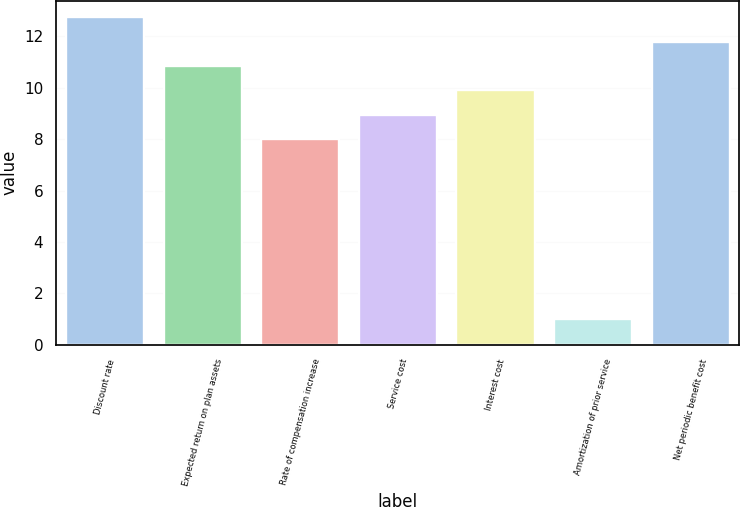Convert chart. <chart><loc_0><loc_0><loc_500><loc_500><bar_chart><fcel>Discount rate<fcel>Expected return on plan assets<fcel>Rate of compensation increase<fcel>Service cost<fcel>Interest cost<fcel>Amortization of prior service<fcel>Net periodic benefit cost<nl><fcel>12.75<fcel>10.85<fcel>8<fcel>8.95<fcel>9.9<fcel>1<fcel>11.8<nl></chart> 